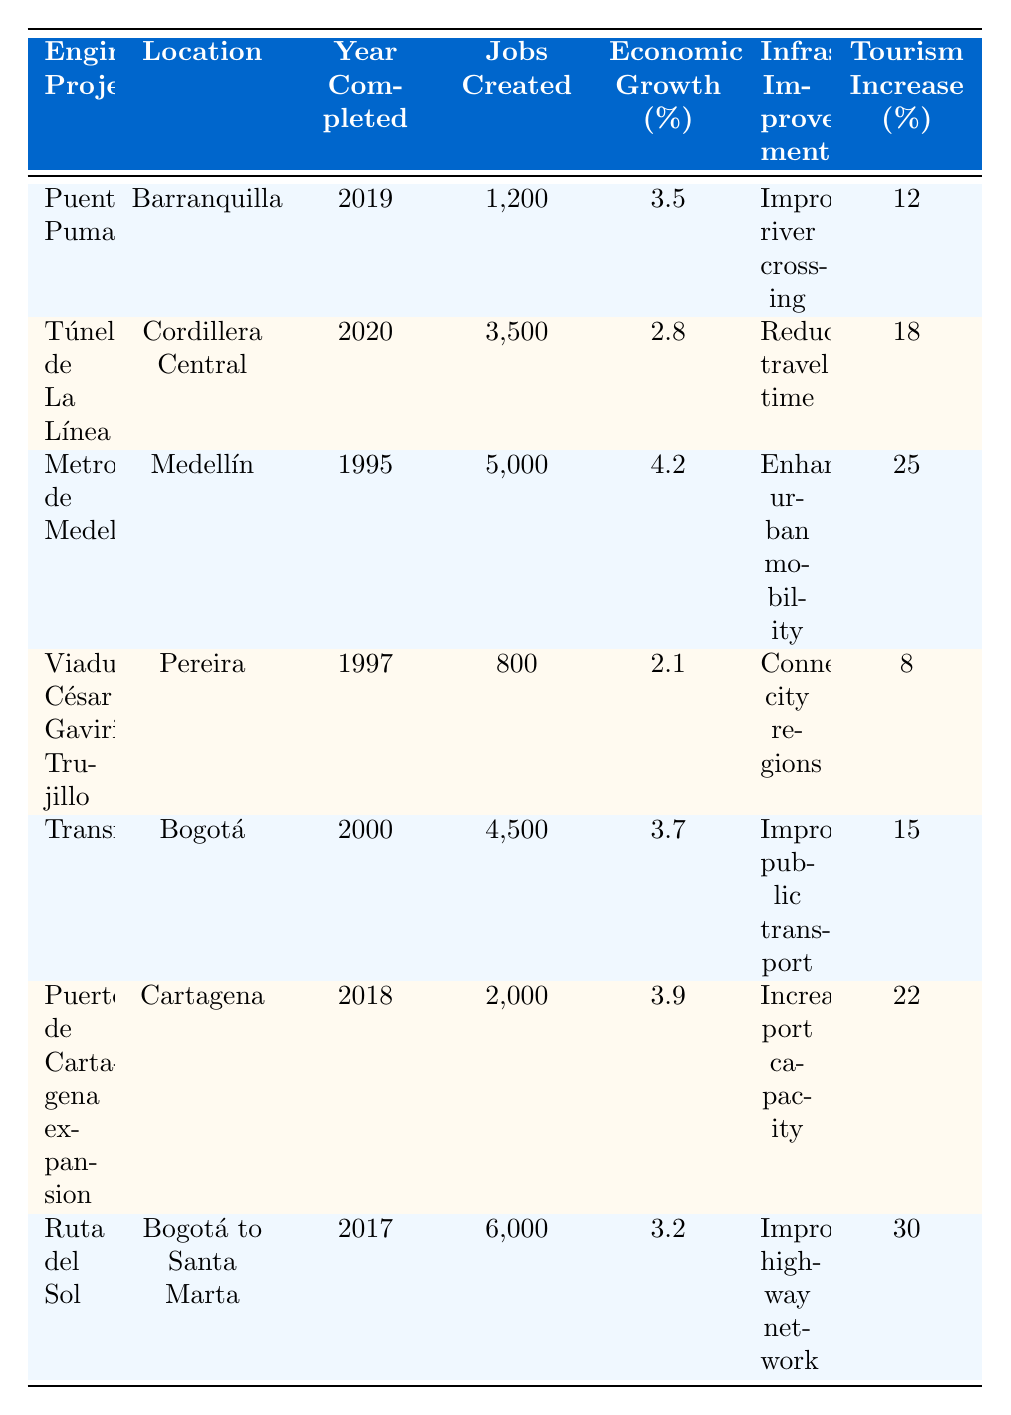What is the location of the Puente Pumarejo project? The table lists "Barranquilla" as the location for the Puente Pumarejo project.
Answer: Barranquilla How many jobs were created by the Túnel de La Línea project? According to the table, the Túnel de La Línea project created 3,500 jobs.
Answer: 3,500 Which project had the highest percentage increase in tourism? The table shows that the Ruta del Sol project had the highest tourism increase at 30%.
Answer: 30% What was the economic growth percentage of the Metro de Medellín project? From the table, the economic growth percentage for the Metro de Medellín project is 4.2%.
Answer: 4.2% Which project was completed most recently? The table indicates that the Puente Pumarejo was completed in 2019, which is the most recent year listed.
Answer: Puente Pumarejo Calculate the total number of jobs created by all listed projects. Summing the jobs created: 1200 + 3500 + 5000 + 800 + 4500 + 2000 + 6000 = 20,000 jobs in total.
Answer: 20,000 Is it true that the Viaducto César Gaviria Trujillo project contributed to tourism increase? Yes, the table states that the Viaducto César Gaviria Trujillo project had a tourism increase of 8%.
Answer: Yes Which project has the lowest economic growth percentage? A comparison of the economic growth percentages reveals that the Viaducto César Gaviria Trujillo has the lowest at 2.1%.
Answer: 2.1% What is the average number of jobs created by the projects listed in the table? The average is calculated by dividing the total jobs created (20,000) by the number of projects (7): 20,000 / 7 ≈ 2857.14, rounded to 2857.
Answer: 2857 Did all projects improve infrastructure? Yes, each project listed in the table includes an "Infrastructure Improvement" entry indicating enhancements made.
Answer: Yes 